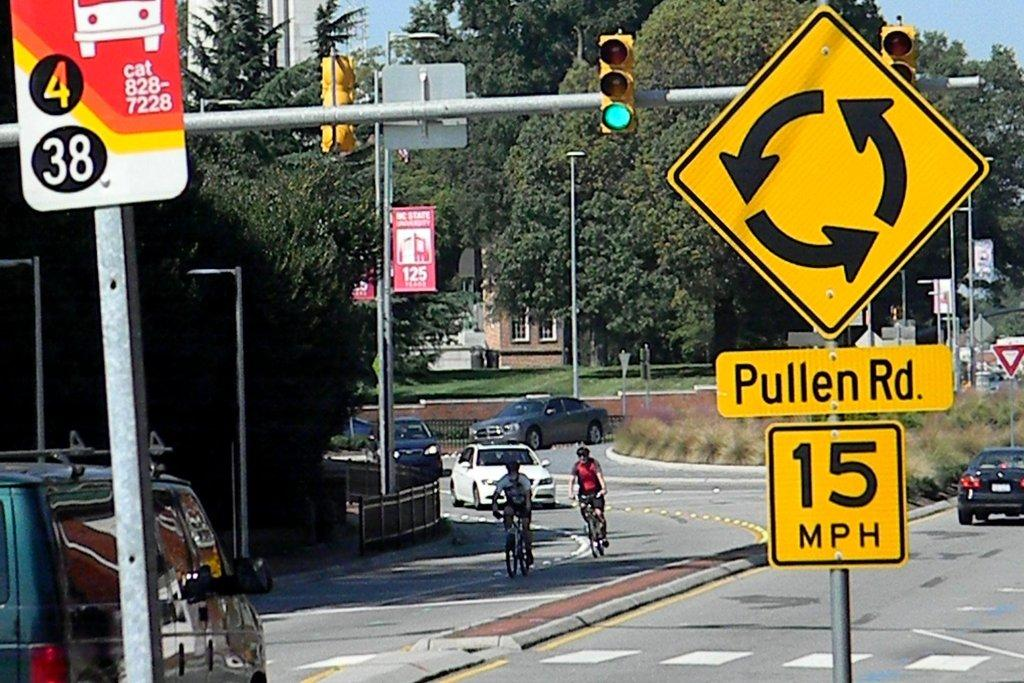<image>
Give a short and clear explanation of the subsequent image. People ride bicycles near a traffic sign with a 15 mile per hour speed limit. 